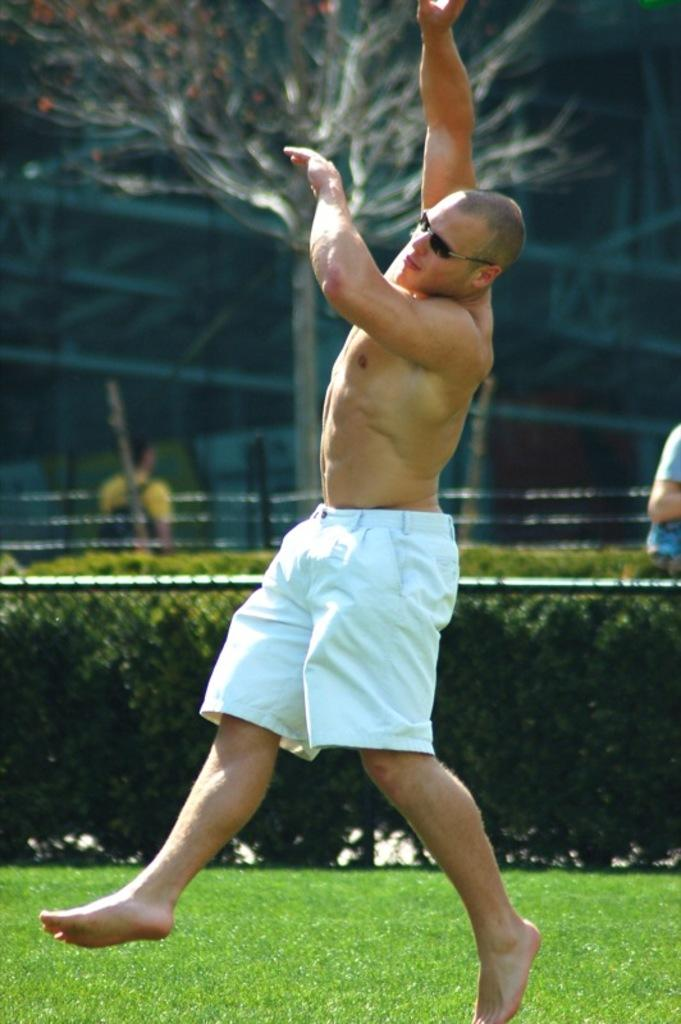What type of vegetation is present in the image? There is grass in the image. How many people are in the image? There are three people in the image. What is the barrier in the image made of? There is a fence in the image, which is likely made of wood or metal. What other types of vegetation can be seen in the image? There are plants and a tree in the image. Can you describe any other objects in the image? There are some unspecified objects in the image, but their nature cannot be determined from the provided facts. What type of veil is draped over the tree in the image? There is no veil present in the image; it only features a tree, grass, plants, a fence, and three people. 